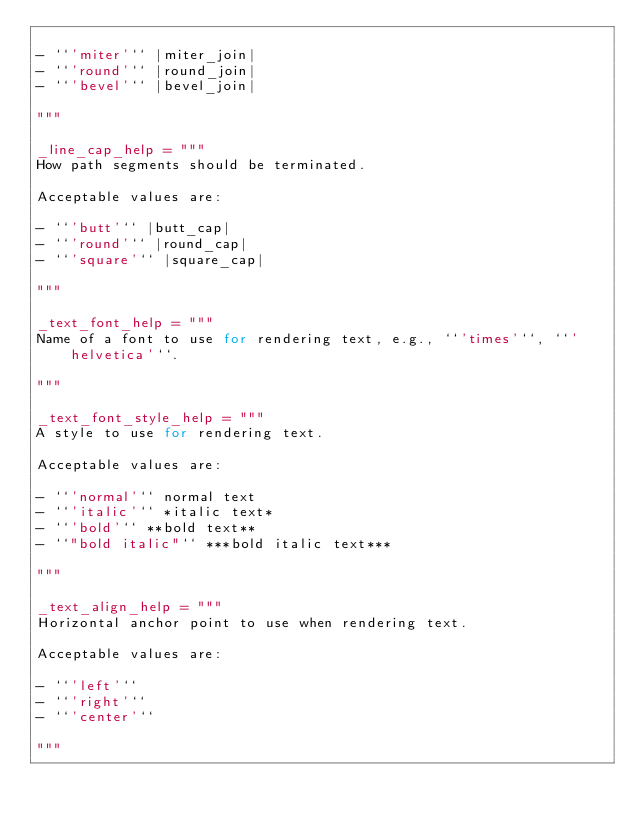<code> <loc_0><loc_0><loc_500><loc_500><_Python_>
- ``'miter'`` |miter_join|
- ``'round'`` |round_join|
- ``'bevel'`` |bevel_join|

"""

_line_cap_help = """
How path segments should be terminated.

Acceptable values are:

- ``'butt'`` |butt_cap|
- ``'round'`` |round_cap|
- ``'square'`` |square_cap|

"""

_text_font_help = """
Name of a font to use for rendering text, e.g., ``'times'``, ``'helvetica'``.

"""

_text_font_style_help = """
A style to use for rendering text.

Acceptable values are:

- ``'normal'`` normal text
- ``'italic'`` *italic text*
- ``'bold'`` **bold text**
- ``"bold italic"`` ***bold italic text***

"""

_text_align_help = """
Horizontal anchor point to use when rendering text.

Acceptable values are:

- ``'left'``
- ``'right'``
- ``'center'``

"""
</code> 